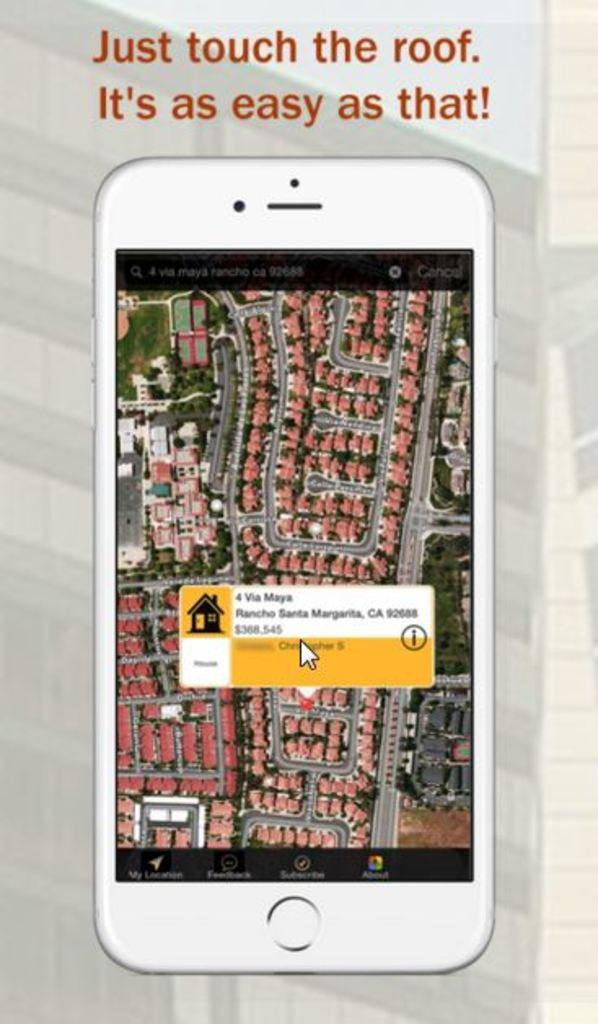<image>
Offer a succinct explanation of the picture presented. a phone with a message of touch the roof above it 